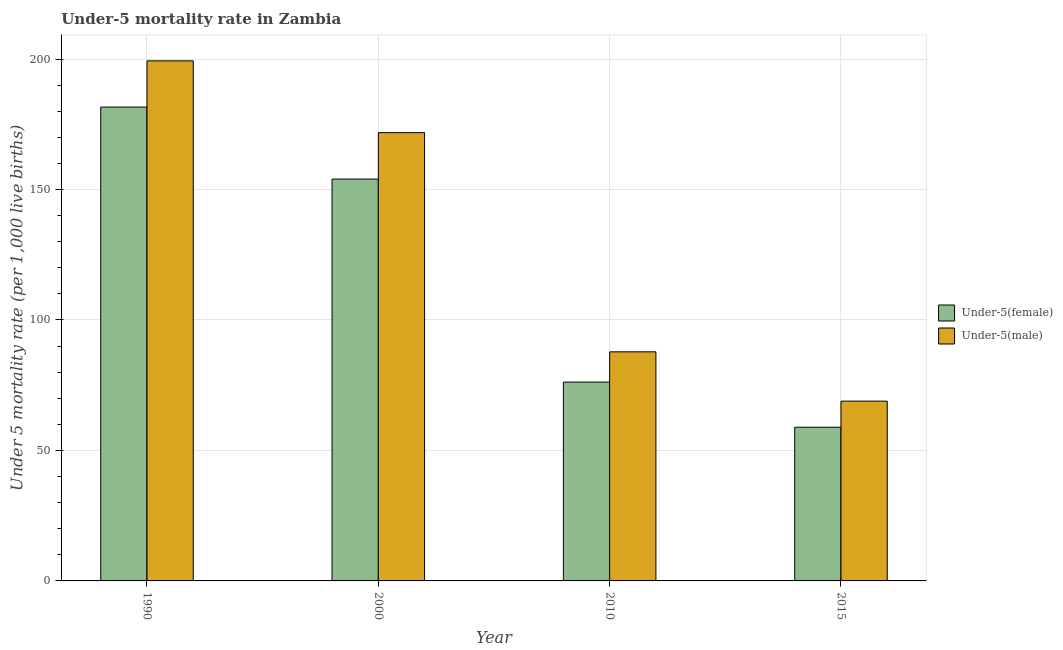Are the number of bars per tick equal to the number of legend labels?
Your answer should be very brief. Yes. Are the number of bars on each tick of the X-axis equal?
Give a very brief answer. Yes. How many bars are there on the 2nd tick from the left?
Provide a succinct answer. 2. In how many cases, is the number of bars for a given year not equal to the number of legend labels?
Make the answer very short. 0. What is the under-5 male mortality rate in 1990?
Offer a terse response. 199.3. Across all years, what is the maximum under-5 male mortality rate?
Offer a very short reply. 199.3. Across all years, what is the minimum under-5 female mortality rate?
Give a very brief answer. 58.9. In which year was the under-5 male mortality rate maximum?
Ensure brevity in your answer.  1990. In which year was the under-5 male mortality rate minimum?
Offer a terse response. 2015. What is the total under-5 male mortality rate in the graph?
Ensure brevity in your answer.  527.8. What is the difference between the under-5 male mortality rate in 1990 and that in 2010?
Your response must be concise. 111.5. What is the difference between the under-5 female mortality rate in 2000 and the under-5 male mortality rate in 2010?
Offer a terse response. 77.8. What is the average under-5 male mortality rate per year?
Your answer should be compact. 131.95. In how many years, is the under-5 male mortality rate greater than 50?
Your answer should be very brief. 4. What is the ratio of the under-5 female mortality rate in 1990 to that in 2000?
Provide a short and direct response. 1.18. Is the under-5 female mortality rate in 2000 less than that in 2015?
Your response must be concise. No. Is the difference between the under-5 female mortality rate in 2010 and 2015 greater than the difference between the under-5 male mortality rate in 2010 and 2015?
Your answer should be very brief. No. What is the difference between the highest and the second highest under-5 male mortality rate?
Provide a succinct answer. 27.5. What is the difference between the highest and the lowest under-5 female mortality rate?
Give a very brief answer. 122.7. Is the sum of the under-5 male mortality rate in 1990 and 2010 greater than the maximum under-5 female mortality rate across all years?
Offer a very short reply. Yes. What does the 1st bar from the left in 2000 represents?
Ensure brevity in your answer.  Under-5(female). What does the 2nd bar from the right in 2010 represents?
Keep it short and to the point. Under-5(female). Are all the bars in the graph horizontal?
Your answer should be very brief. No. What is the difference between two consecutive major ticks on the Y-axis?
Your answer should be compact. 50. Are the values on the major ticks of Y-axis written in scientific E-notation?
Give a very brief answer. No. How are the legend labels stacked?
Your answer should be very brief. Vertical. What is the title of the graph?
Keep it short and to the point. Under-5 mortality rate in Zambia. What is the label or title of the Y-axis?
Provide a succinct answer. Under 5 mortality rate (per 1,0 live births). What is the Under 5 mortality rate (per 1,000 live births) in Under-5(female) in 1990?
Your response must be concise. 181.6. What is the Under 5 mortality rate (per 1,000 live births) in Under-5(male) in 1990?
Offer a terse response. 199.3. What is the Under 5 mortality rate (per 1,000 live births) in Under-5(female) in 2000?
Make the answer very short. 154. What is the Under 5 mortality rate (per 1,000 live births) of Under-5(male) in 2000?
Ensure brevity in your answer.  171.8. What is the Under 5 mortality rate (per 1,000 live births) of Under-5(female) in 2010?
Make the answer very short. 76.2. What is the Under 5 mortality rate (per 1,000 live births) of Under-5(male) in 2010?
Ensure brevity in your answer.  87.8. What is the Under 5 mortality rate (per 1,000 live births) in Under-5(female) in 2015?
Provide a succinct answer. 58.9. What is the Under 5 mortality rate (per 1,000 live births) in Under-5(male) in 2015?
Offer a terse response. 68.9. Across all years, what is the maximum Under 5 mortality rate (per 1,000 live births) of Under-5(female)?
Your answer should be compact. 181.6. Across all years, what is the maximum Under 5 mortality rate (per 1,000 live births) of Under-5(male)?
Make the answer very short. 199.3. Across all years, what is the minimum Under 5 mortality rate (per 1,000 live births) in Under-5(female)?
Provide a short and direct response. 58.9. Across all years, what is the minimum Under 5 mortality rate (per 1,000 live births) of Under-5(male)?
Give a very brief answer. 68.9. What is the total Under 5 mortality rate (per 1,000 live births) of Under-5(female) in the graph?
Keep it short and to the point. 470.7. What is the total Under 5 mortality rate (per 1,000 live births) in Under-5(male) in the graph?
Offer a very short reply. 527.8. What is the difference between the Under 5 mortality rate (per 1,000 live births) of Under-5(female) in 1990 and that in 2000?
Provide a succinct answer. 27.6. What is the difference between the Under 5 mortality rate (per 1,000 live births) in Under-5(male) in 1990 and that in 2000?
Your answer should be compact. 27.5. What is the difference between the Under 5 mortality rate (per 1,000 live births) in Under-5(female) in 1990 and that in 2010?
Offer a terse response. 105.4. What is the difference between the Under 5 mortality rate (per 1,000 live births) of Under-5(male) in 1990 and that in 2010?
Provide a succinct answer. 111.5. What is the difference between the Under 5 mortality rate (per 1,000 live births) in Under-5(female) in 1990 and that in 2015?
Your answer should be very brief. 122.7. What is the difference between the Under 5 mortality rate (per 1,000 live births) in Under-5(male) in 1990 and that in 2015?
Keep it short and to the point. 130.4. What is the difference between the Under 5 mortality rate (per 1,000 live births) in Under-5(female) in 2000 and that in 2010?
Give a very brief answer. 77.8. What is the difference between the Under 5 mortality rate (per 1,000 live births) in Under-5(female) in 2000 and that in 2015?
Ensure brevity in your answer.  95.1. What is the difference between the Under 5 mortality rate (per 1,000 live births) of Under-5(male) in 2000 and that in 2015?
Provide a short and direct response. 102.9. What is the difference between the Under 5 mortality rate (per 1,000 live births) in Under-5(female) in 2010 and that in 2015?
Provide a succinct answer. 17.3. What is the difference between the Under 5 mortality rate (per 1,000 live births) of Under-5(male) in 2010 and that in 2015?
Provide a short and direct response. 18.9. What is the difference between the Under 5 mortality rate (per 1,000 live births) in Under-5(female) in 1990 and the Under 5 mortality rate (per 1,000 live births) in Under-5(male) in 2010?
Give a very brief answer. 93.8. What is the difference between the Under 5 mortality rate (per 1,000 live births) of Under-5(female) in 1990 and the Under 5 mortality rate (per 1,000 live births) of Under-5(male) in 2015?
Give a very brief answer. 112.7. What is the difference between the Under 5 mortality rate (per 1,000 live births) of Under-5(female) in 2000 and the Under 5 mortality rate (per 1,000 live births) of Under-5(male) in 2010?
Offer a very short reply. 66.2. What is the difference between the Under 5 mortality rate (per 1,000 live births) of Under-5(female) in 2000 and the Under 5 mortality rate (per 1,000 live births) of Under-5(male) in 2015?
Your answer should be very brief. 85.1. What is the difference between the Under 5 mortality rate (per 1,000 live births) of Under-5(female) in 2010 and the Under 5 mortality rate (per 1,000 live births) of Under-5(male) in 2015?
Provide a succinct answer. 7.3. What is the average Under 5 mortality rate (per 1,000 live births) of Under-5(female) per year?
Provide a short and direct response. 117.67. What is the average Under 5 mortality rate (per 1,000 live births) in Under-5(male) per year?
Provide a succinct answer. 131.95. In the year 1990, what is the difference between the Under 5 mortality rate (per 1,000 live births) of Under-5(female) and Under 5 mortality rate (per 1,000 live births) of Under-5(male)?
Offer a very short reply. -17.7. In the year 2000, what is the difference between the Under 5 mortality rate (per 1,000 live births) in Under-5(female) and Under 5 mortality rate (per 1,000 live births) in Under-5(male)?
Give a very brief answer. -17.8. In the year 2010, what is the difference between the Under 5 mortality rate (per 1,000 live births) of Under-5(female) and Under 5 mortality rate (per 1,000 live births) of Under-5(male)?
Keep it short and to the point. -11.6. What is the ratio of the Under 5 mortality rate (per 1,000 live births) of Under-5(female) in 1990 to that in 2000?
Your response must be concise. 1.18. What is the ratio of the Under 5 mortality rate (per 1,000 live births) in Under-5(male) in 1990 to that in 2000?
Provide a short and direct response. 1.16. What is the ratio of the Under 5 mortality rate (per 1,000 live births) of Under-5(female) in 1990 to that in 2010?
Ensure brevity in your answer.  2.38. What is the ratio of the Under 5 mortality rate (per 1,000 live births) of Under-5(male) in 1990 to that in 2010?
Give a very brief answer. 2.27. What is the ratio of the Under 5 mortality rate (per 1,000 live births) in Under-5(female) in 1990 to that in 2015?
Offer a very short reply. 3.08. What is the ratio of the Under 5 mortality rate (per 1,000 live births) of Under-5(male) in 1990 to that in 2015?
Make the answer very short. 2.89. What is the ratio of the Under 5 mortality rate (per 1,000 live births) of Under-5(female) in 2000 to that in 2010?
Make the answer very short. 2.02. What is the ratio of the Under 5 mortality rate (per 1,000 live births) in Under-5(male) in 2000 to that in 2010?
Offer a terse response. 1.96. What is the ratio of the Under 5 mortality rate (per 1,000 live births) of Under-5(female) in 2000 to that in 2015?
Your answer should be very brief. 2.61. What is the ratio of the Under 5 mortality rate (per 1,000 live births) of Under-5(male) in 2000 to that in 2015?
Your answer should be very brief. 2.49. What is the ratio of the Under 5 mortality rate (per 1,000 live births) of Under-5(female) in 2010 to that in 2015?
Provide a succinct answer. 1.29. What is the ratio of the Under 5 mortality rate (per 1,000 live births) in Under-5(male) in 2010 to that in 2015?
Make the answer very short. 1.27. What is the difference between the highest and the second highest Under 5 mortality rate (per 1,000 live births) in Under-5(female)?
Offer a terse response. 27.6. What is the difference between the highest and the lowest Under 5 mortality rate (per 1,000 live births) in Under-5(female)?
Provide a short and direct response. 122.7. What is the difference between the highest and the lowest Under 5 mortality rate (per 1,000 live births) in Under-5(male)?
Your response must be concise. 130.4. 